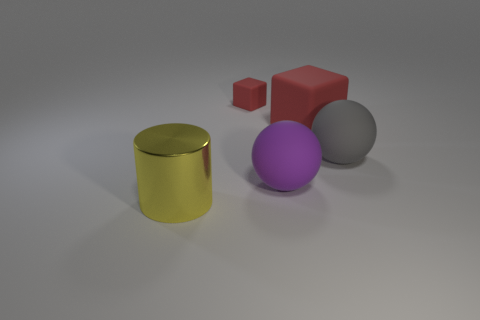There is a red object that is the same size as the yellow metal thing; what is its material? The red object appears to have a matte finish and does not reflect light in the same way the yellow metal cylinder does, suggesting it may not be made of metal. While it's difficult to determine the exact material without further context, a common non-reflective, non-metal material for objects like this could be plastic or painted wood. 